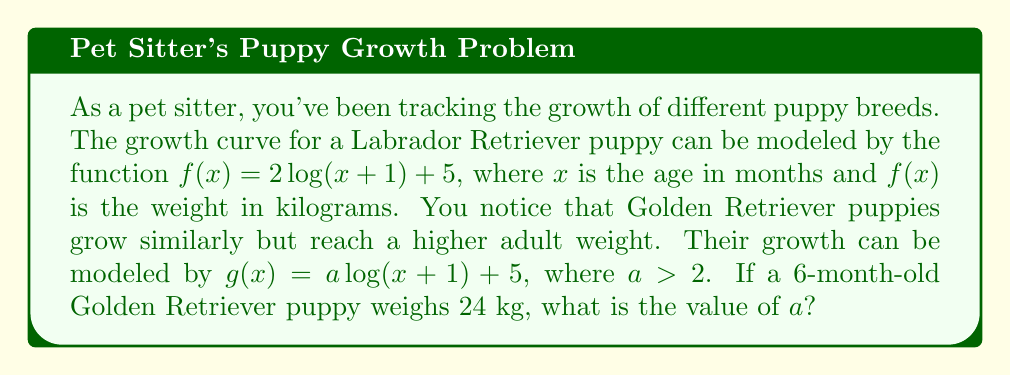Teach me how to tackle this problem. Let's approach this step-by-step:

1) We know that for a 6-month-old Golden Retriever puppy:
   $x = 6$ and $g(6) = 24$

2) Substituting these values into the function $g(x) = a\log(x+1) + 5$:
   $24 = a\log(6+1) + 5$

3) Simplify:
   $24 = a\log(7) + 5$

4) Subtract 5 from both sides:
   $19 = a\log(7)$

5) Divide both sides by $\log(7)$:
   $\frac{19}{\log(7)} = a$

6) Calculate the value of $\log(7)$ (using base e logarithm):
   $\log(7) \approx 1.9459$

7) Therefore:
   $a \approx \frac{19}{1.9459} \approx 9.7641$

8) Round to two decimal places:
   $a \approx 9.76$

This value of $a$ is indeed greater than 2, which aligns with the given information that Golden Retrievers grow to a larger size than Labrador Retrievers.
Answer: $a \approx 9.76$ 